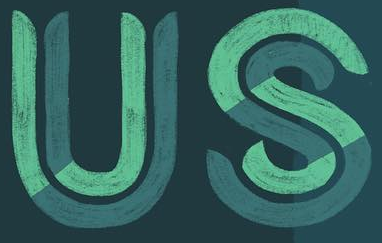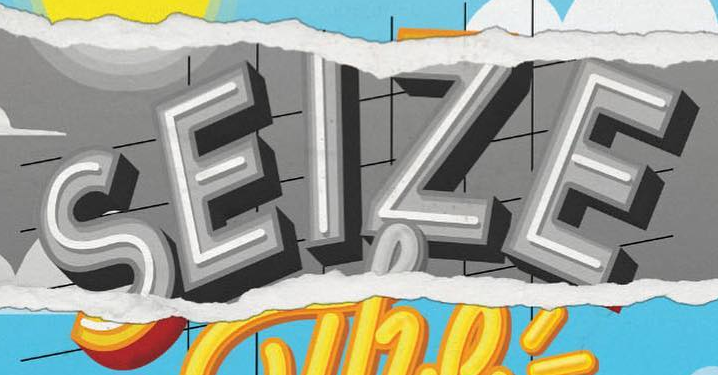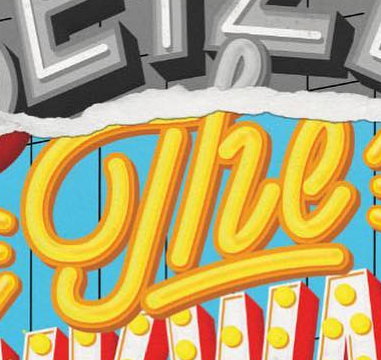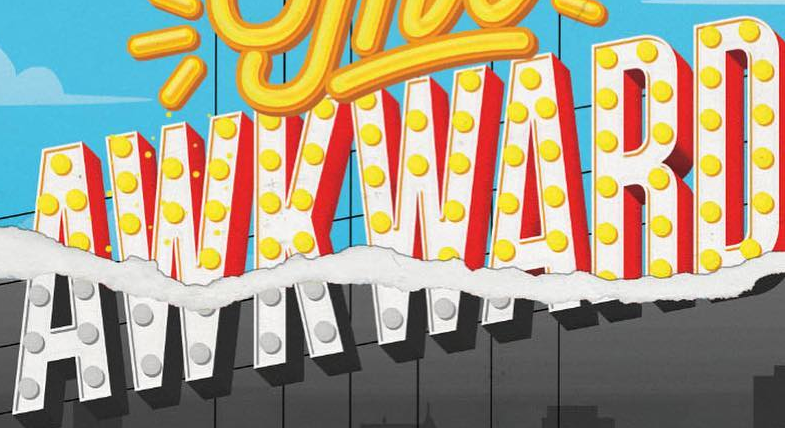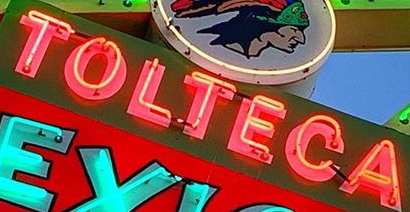What words can you see in these images in sequence, separated by a semicolon? US; SEIZE; The; AWKWARD; TOLTECA 